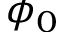Convert formula to latex. <formula><loc_0><loc_0><loc_500><loc_500>\phi _ { 0 }</formula> 